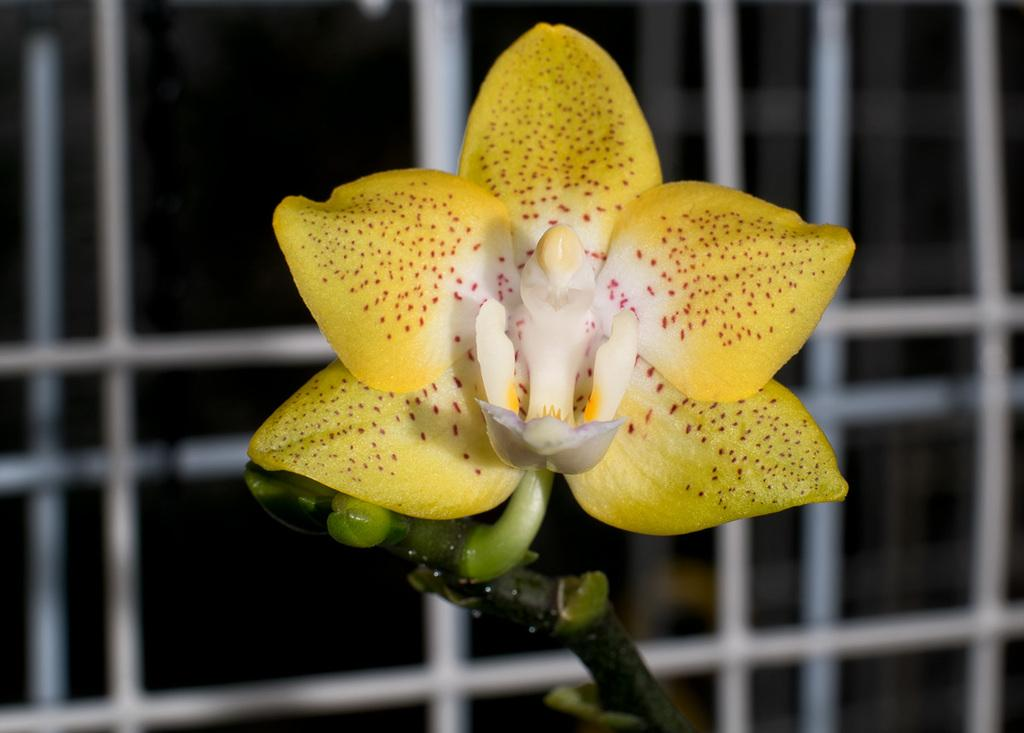What type of flower is in the image? There is a yellow color flower in the image. Where is the flower located in the image? The flower is in the front of the image. What else can be seen in the image besides the flower? There is a white color window grill in the image. How many yams are placed on the window grill in the image? There are no yams present in the image; it features a yellow color flower and a white color window grill. Can you see a nest in the image? There is no nest visible in the image. 